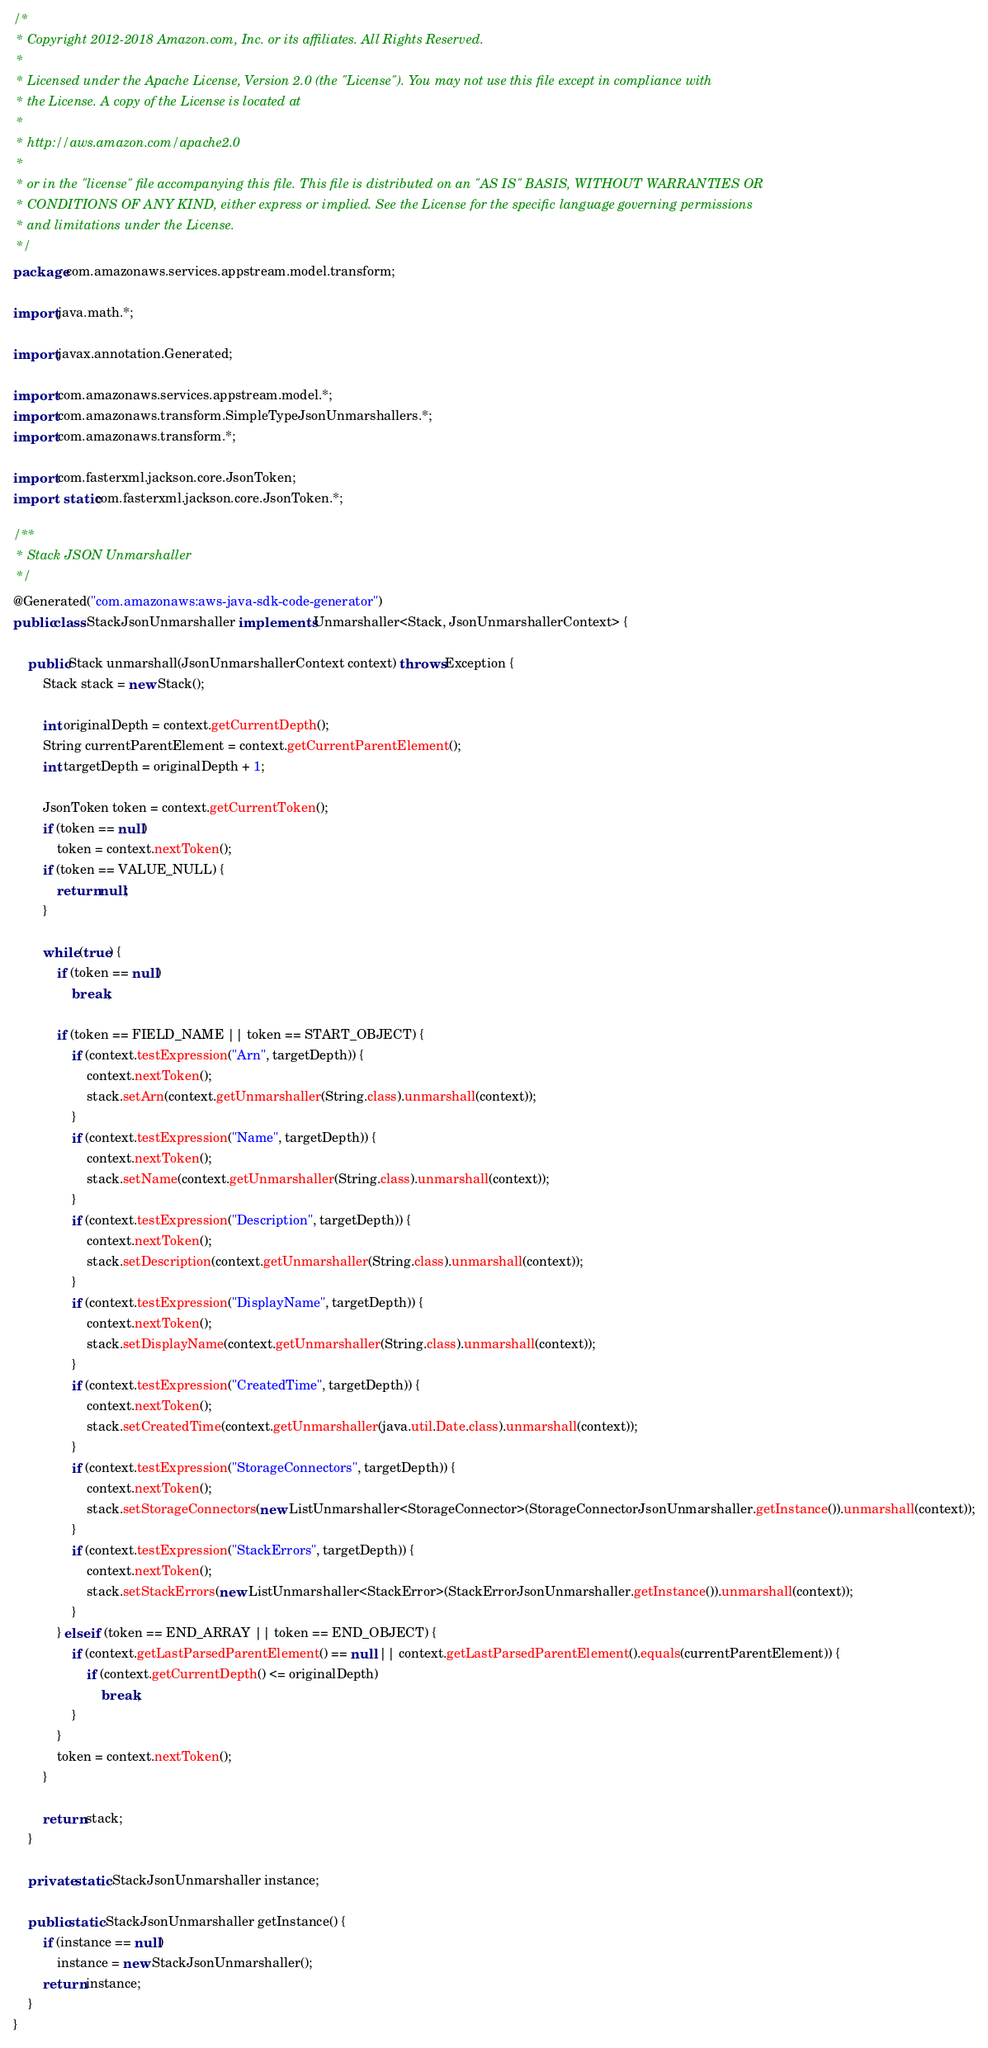<code> <loc_0><loc_0><loc_500><loc_500><_Java_>/*
 * Copyright 2012-2018 Amazon.com, Inc. or its affiliates. All Rights Reserved.
 * 
 * Licensed under the Apache License, Version 2.0 (the "License"). You may not use this file except in compliance with
 * the License. A copy of the License is located at
 * 
 * http://aws.amazon.com/apache2.0
 * 
 * or in the "license" file accompanying this file. This file is distributed on an "AS IS" BASIS, WITHOUT WARRANTIES OR
 * CONDITIONS OF ANY KIND, either express or implied. See the License for the specific language governing permissions
 * and limitations under the License.
 */
package com.amazonaws.services.appstream.model.transform;

import java.math.*;

import javax.annotation.Generated;

import com.amazonaws.services.appstream.model.*;
import com.amazonaws.transform.SimpleTypeJsonUnmarshallers.*;
import com.amazonaws.transform.*;

import com.fasterxml.jackson.core.JsonToken;
import static com.fasterxml.jackson.core.JsonToken.*;

/**
 * Stack JSON Unmarshaller
 */
@Generated("com.amazonaws:aws-java-sdk-code-generator")
public class StackJsonUnmarshaller implements Unmarshaller<Stack, JsonUnmarshallerContext> {

    public Stack unmarshall(JsonUnmarshallerContext context) throws Exception {
        Stack stack = new Stack();

        int originalDepth = context.getCurrentDepth();
        String currentParentElement = context.getCurrentParentElement();
        int targetDepth = originalDepth + 1;

        JsonToken token = context.getCurrentToken();
        if (token == null)
            token = context.nextToken();
        if (token == VALUE_NULL) {
            return null;
        }

        while (true) {
            if (token == null)
                break;

            if (token == FIELD_NAME || token == START_OBJECT) {
                if (context.testExpression("Arn", targetDepth)) {
                    context.nextToken();
                    stack.setArn(context.getUnmarshaller(String.class).unmarshall(context));
                }
                if (context.testExpression("Name", targetDepth)) {
                    context.nextToken();
                    stack.setName(context.getUnmarshaller(String.class).unmarshall(context));
                }
                if (context.testExpression("Description", targetDepth)) {
                    context.nextToken();
                    stack.setDescription(context.getUnmarshaller(String.class).unmarshall(context));
                }
                if (context.testExpression("DisplayName", targetDepth)) {
                    context.nextToken();
                    stack.setDisplayName(context.getUnmarshaller(String.class).unmarshall(context));
                }
                if (context.testExpression("CreatedTime", targetDepth)) {
                    context.nextToken();
                    stack.setCreatedTime(context.getUnmarshaller(java.util.Date.class).unmarshall(context));
                }
                if (context.testExpression("StorageConnectors", targetDepth)) {
                    context.nextToken();
                    stack.setStorageConnectors(new ListUnmarshaller<StorageConnector>(StorageConnectorJsonUnmarshaller.getInstance()).unmarshall(context));
                }
                if (context.testExpression("StackErrors", targetDepth)) {
                    context.nextToken();
                    stack.setStackErrors(new ListUnmarshaller<StackError>(StackErrorJsonUnmarshaller.getInstance()).unmarshall(context));
                }
            } else if (token == END_ARRAY || token == END_OBJECT) {
                if (context.getLastParsedParentElement() == null || context.getLastParsedParentElement().equals(currentParentElement)) {
                    if (context.getCurrentDepth() <= originalDepth)
                        break;
                }
            }
            token = context.nextToken();
        }

        return stack;
    }

    private static StackJsonUnmarshaller instance;

    public static StackJsonUnmarshaller getInstance() {
        if (instance == null)
            instance = new StackJsonUnmarshaller();
        return instance;
    }
}
</code> 